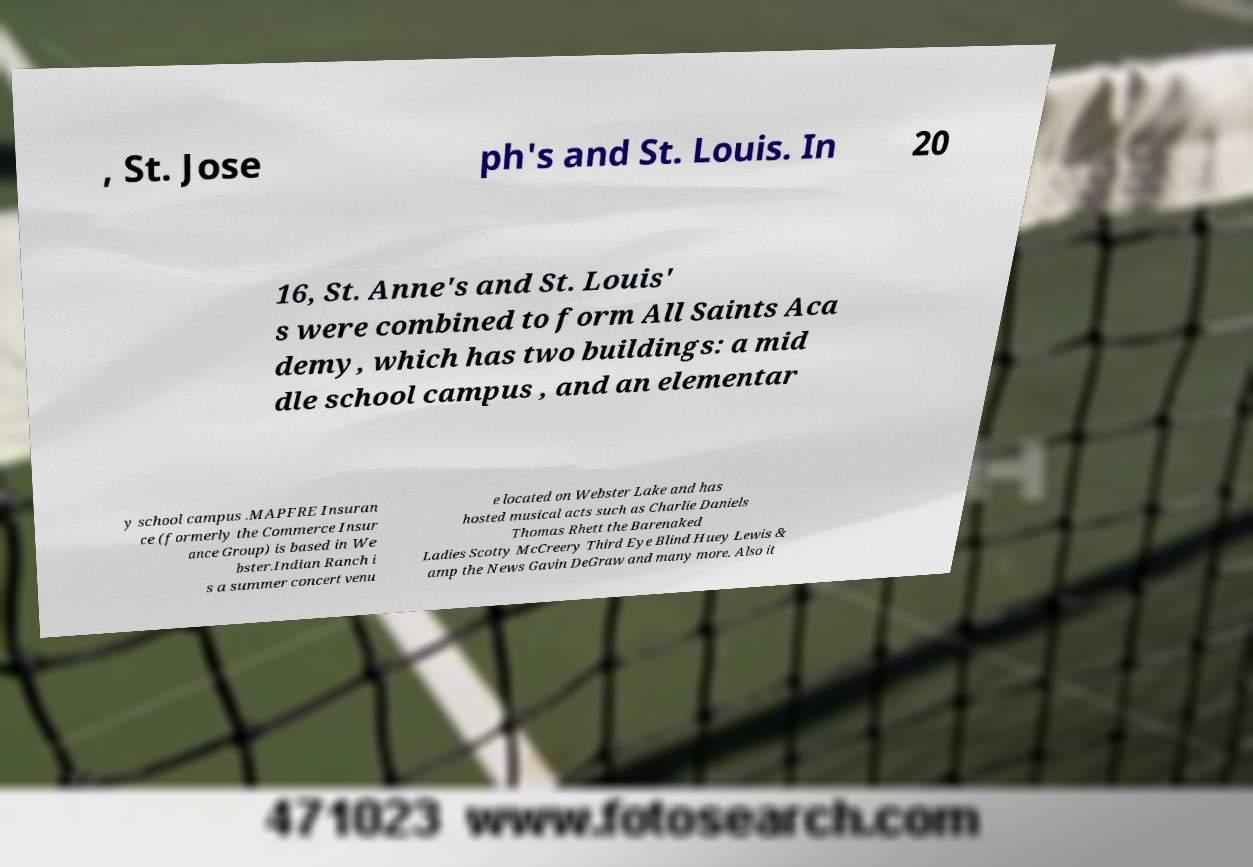Please read and relay the text visible in this image. What does it say? , St. Jose ph's and St. Louis. In 20 16, St. Anne's and St. Louis' s were combined to form All Saints Aca demy, which has two buildings: a mid dle school campus , and an elementar y school campus .MAPFRE Insuran ce (formerly the Commerce Insur ance Group) is based in We bster.Indian Ranch i s a summer concert venu e located on Webster Lake and has hosted musical acts such as Charlie Daniels Thomas Rhett the Barenaked Ladies Scotty McCreery Third Eye Blind Huey Lewis & amp the News Gavin DeGraw and many more. Also it 